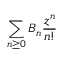Convert formula to latex. <formula><loc_0><loc_0><loc_500><loc_500>\sum _ { n \geq 0 } B _ { n } { \frac { z ^ { n } } { n ! } }</formula> 